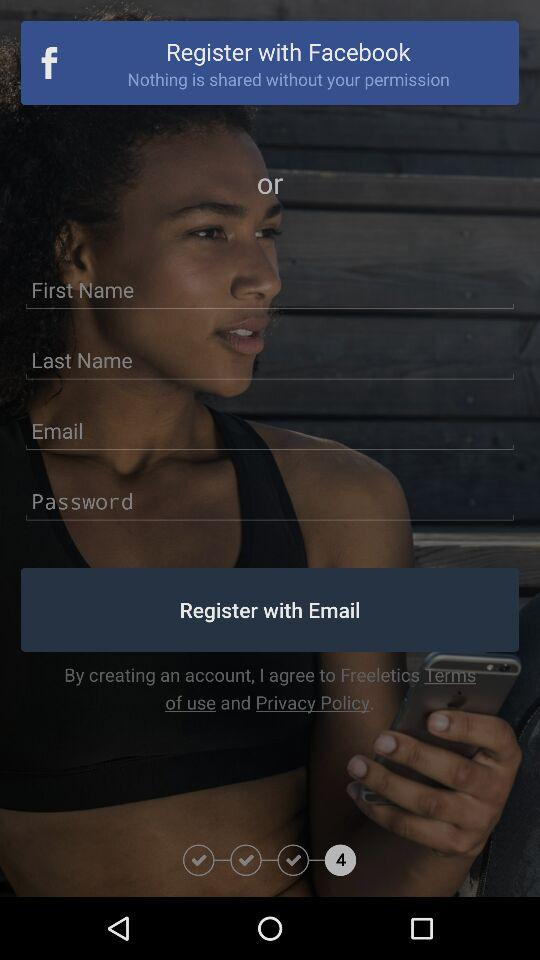At which step am I? You are at step 4. 